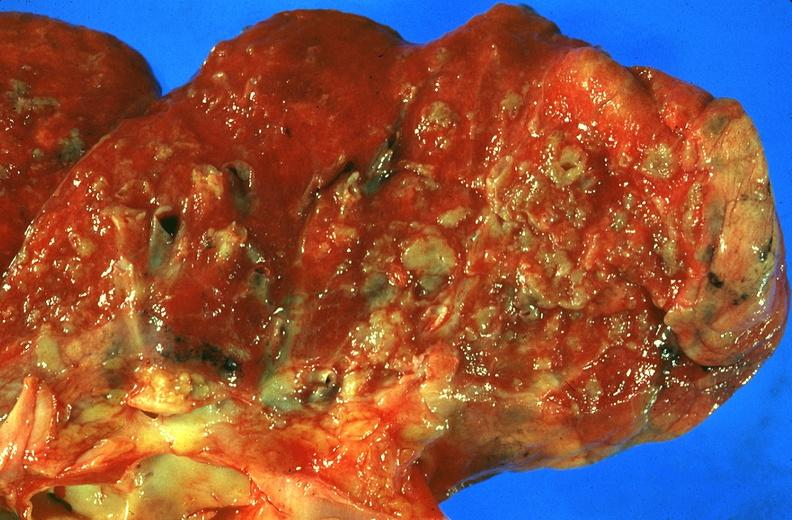does hyperplasia median bar show lung, sarcoidosis?
Answer the question using a single word or phrase. No 